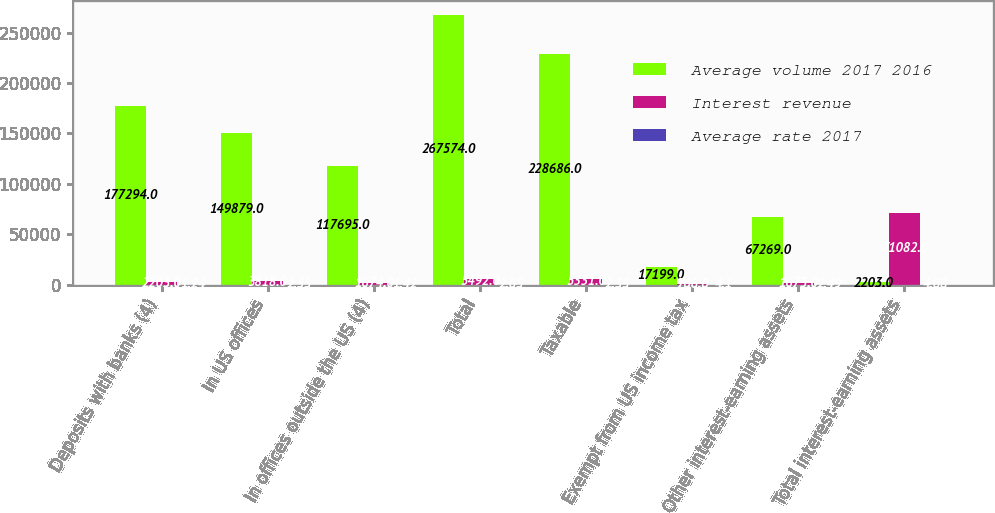Convert chart. <chart><loc_0><loc_0><loc_500><loc_500><stacked_bar_chart><ecel><fcel>Deposits with banks (4)<fcel>In US offices<fcel>In offices outside the US (4)<fcel>Total<fcel>Taxable<fcel>Exempt from US income tax<fcel>Other interest-earning assets<fcel>Total interest-earning assets<nl><fcel>Average volume 2017 2016<fcel>177294<fcel>149879<fcel>117695<fcel>267574<fcel>228686<fcel>17199<fcel>67269<fcel>2203<nl><fcel>Interest revenue<fcel>2203<fcel>3818<fcel>1674<fcel>5492<fcel>5331<fcel>706<fcel>1673<fcel>71082<nl><fcel>Average rate 2017<fcel>1.24<fcel>2.55<fcel>1.42<fcel>2.05<fcel>2.33<fcel>4.1<fcel>2.49<fcel>4.08<nl></chart> 